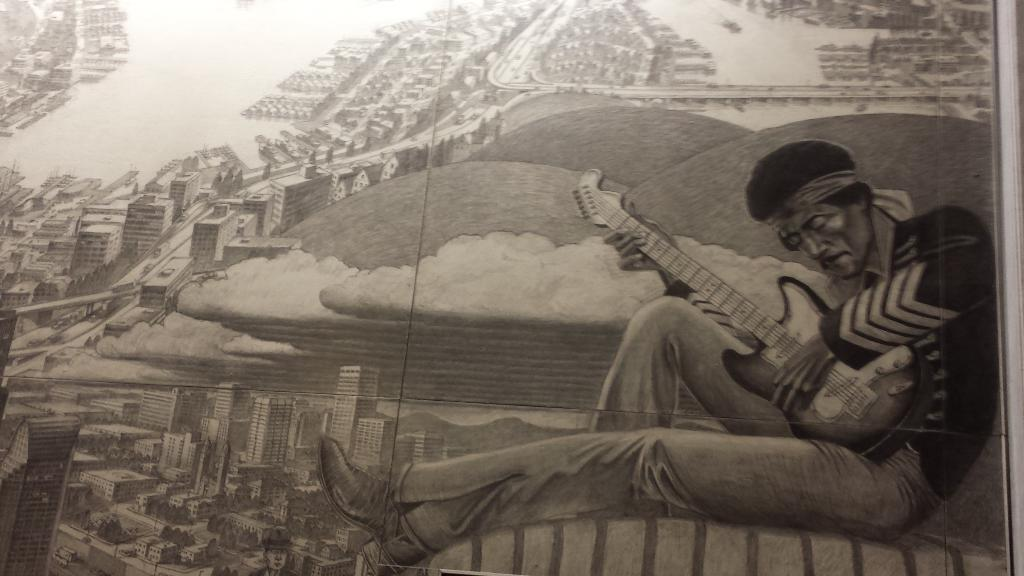What is the main subject of the sketch in the image? The main subject of the sketch in the image is buildings. Can you describe the person in the image? There is a man in the image, and he is sitting. What is the man holding in his hands? The man is holding a guitar in his hands. What is the color scheme of the image? The image is black and white in color. How many chickens are present in the image? There are no chickens present in the image; it contains a sketch of buildings and a man holding a guitar. What type of guide is the man providing in the image? There is no indication in the image that the man is providing any type of guide or service. 